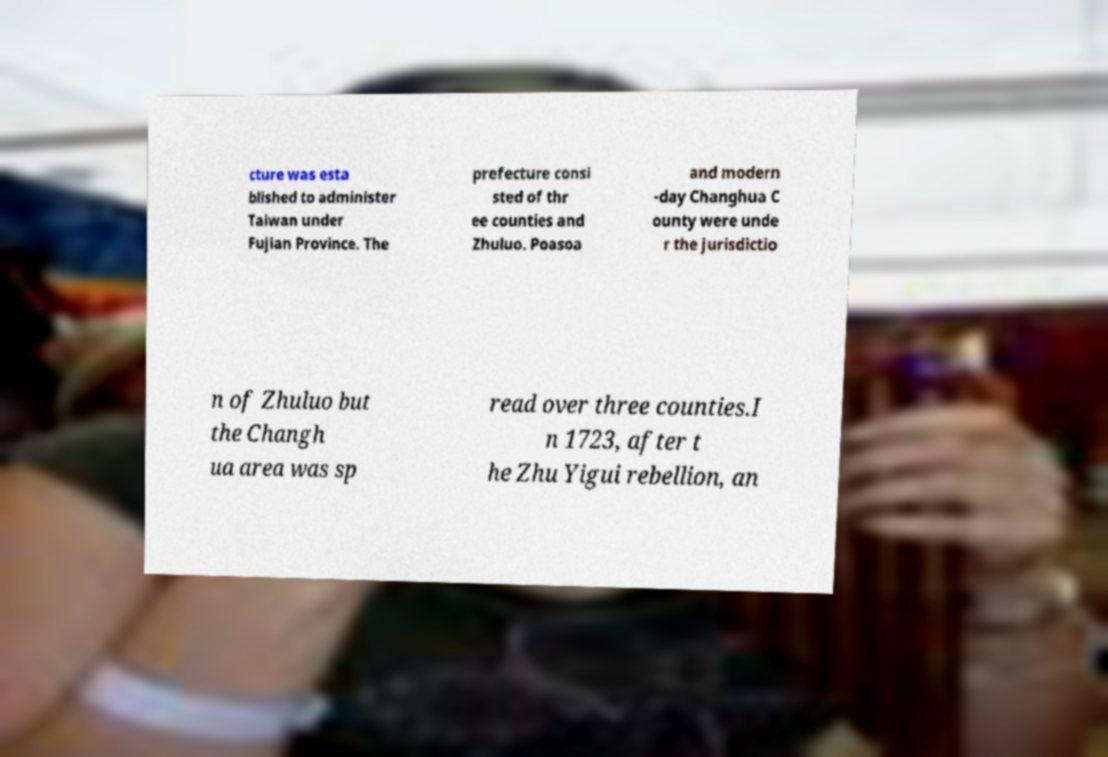Can you accurately transcribe the text from the provided image for me? cture was esta blished to administer Taiwan under Fujian Province. The prefecture consi sted of thr ee counties and Zhuluo. Poasoa and modern -day Changhua C ounty were unde r the jurisdictio n of Zhuluo but the Changh ua area was sp read over three counties.I n 1723, after t he Zhu Yigui rebellion, an 